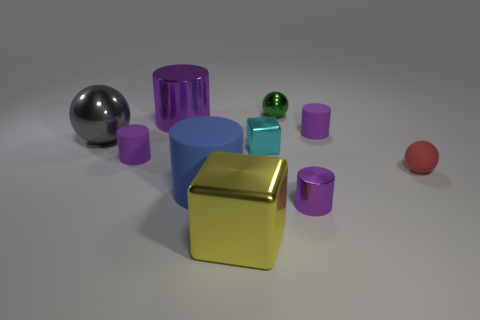Can you tell me about the different shapes in this image? Certainly! The image displays a collection of 3D objects with various shapes: there are cylinders, spheres, a cube, and what appears to be a partial torus or a circular object. The cube has a reflective gold surface, and the rest include matte purple cylinders, a chrome-like sphere, and the green sphere we previously discussed.  Are there any patterns or themes to the arrangement of these objects? While the objects are randomly placed, one could interpret the arrangement as a deliberate study of contrasts - in colors, shapes, and textures. You have shiny versus matte finishes, and vivid versus subdued colors, indicating a possible theme of diversity or contrast. 